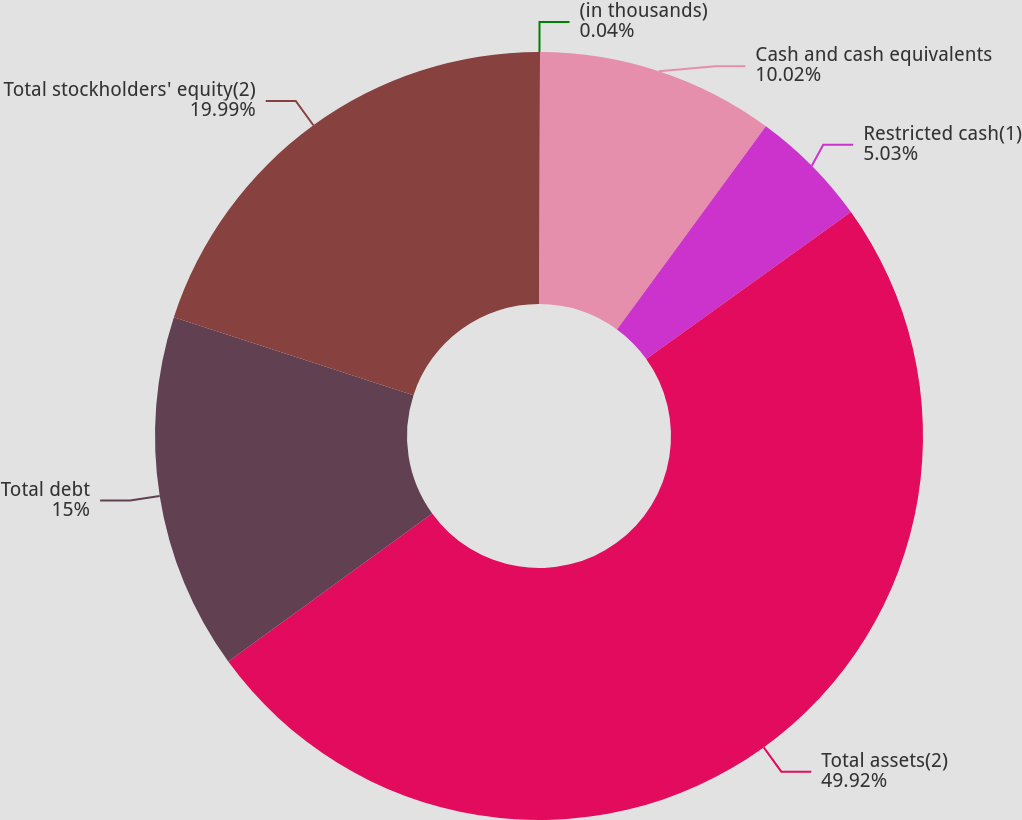Convert chart. <chart><loc_0><loc_0><loc_500><loc_500><pie_chart><fcel>(in thousands)<fcel>Cash and cash equivalents<fcel>Restricted cash(1)<fcel>Total assets(2)<fcel>Total debt<fcel>Total stockholders' equity(2)<nl><fcel>0.04%<fcel>10.02%<fcel>5.03%<fcel>49.91%<fcel>15.0%<fcel>19.99%<nl></chart> 